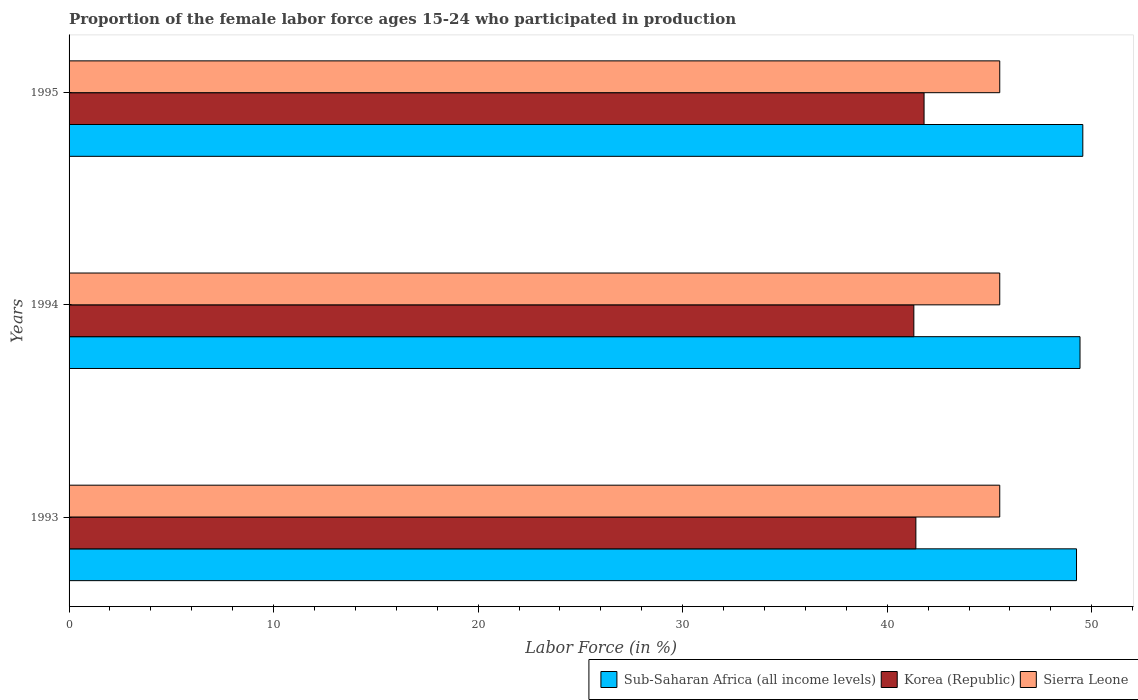Are the number of bars per tick equal to the number of legend labels?
Offer a very short reply. Yes. Are the number of bars on each tick of the Y-axis equal?
Offer a very short reply. Yes. How many bars are there on the 1st tick from the top?
Ensure brevity in your answer.  3. In how many cases, is the number of bars for a given year not equal to the number of legend labels?
Give a very brief answer. 0. What is the proportion of the female labor force who participated in production in Sub-Saharan Africa (all income levels) in 1994?
Your answer should be compact. 49.42. Across all years, what is the maximum proportion of the female labor force who participated in production in Korea (Republic)?
Offer a very short reply. 41.8. Across all years, what is the minimum proportion of the female labor force who participated in production in Sierra Leone?
Keep it short and to the point. 45.5. In which year was the proportion of the female labor force who participated in production in Korea (Republic) minimum?
Your answer should be compact. 1994. What is the total proportion of the female labor force who participated in production in Sierra Leone in the graph?
Offer a terse response. 136.5. What is the difference between the proportion of the female labor force who participated in production in Korea (Republic) in 1994 and that in 1995?
Offer a terse response. -0.5. What is the difference between the proportion of the female labor force who participated in production in Sierra Leone in 1993 and the proportion of the female labor force who participated in production in Korea (Republic) in 1994?
Offer a terse response. 4.2. What is the average proportion of the female labor force who participated in production in Korea (Republic) per year?
Your response must be concise. 41.5. In the year 1993, what is the difference between the proportion of the female labor force who participated in production in Sub-Saharan Africa (all income levels) and proportion of the female labor force who participated in production in Korea (Republic)?
Offer a terse response. 7.85. What is the ratio of the proportion of the female labor force who participated in production in Sub-Saharan Africa (all income levels) in 1994 to that in 1995?
Give a very brief answer. 1. Is the proportion of the female labor force who participated in production in Korea (Republic) in 1993 less than that in 1995?
Your response must be concise. Yes. Is the difference between the proportion of the female labor force who participated in production in Sub-Saharan Africa (all income levels) in 1993 and 1994 greater than the difference between the proportion of the female labor force who participated in production in Korea (Republic) in 1993 and 1994?
Give a very brief answer. No. What is the difference between the highest and the second highest proportion of the female labor force who participated in production in Korea (Republic)?
Keep it short and to the point. 0.4. In how many years, is the proportion of the female labor force who participated in production in Sierra Leone greater than the average proportion of the female labor force who participated in production in Sierra Leone taken over all years?
Provide a succinct answer. 0. What does the 3rd bar from the top in 1994 represents?
Provide a short and direct response. Sub-Saharan Africa (all income levels). What does the 1st bar from the bottom in 1995 represents?
Your answer should be compact. Sub-Saharan Africa (all income levels). Is it the case that in every year, the sum of the proportion of the female labor force who participated in production in Sub-Saharan Africa (all income levels) and proportion of the female labor force who participated in production in Korea (Republic) is greater than the proportion of the female labor force who participated in production in Sierra Leone?
Your answer should be very brief. Yes. How many bars are there?
Keep it short and to the point. 9. Are all the bars in the graph horizontal?
Provide a short and direct response. Yes. What is the difference between two consecutive major ticks on the X-axis?
Keep it short and to the point. 10. Where does the legend appear in the graph?
Make the answer very short. Bottom right. How many legend labels are there?
Provide a short and direct response. 3. How are the legend labels stacked?
Offer a terse response. Horizontal. What is the title of the graph?
Ensure brevity in your answer.  Proportion of the female labor force ages 15-24 who participated in production. What is the label or title of the X-axis?
Ensure brevity in your answer.  Labor Force (in %). What is the label or title of the Y-axis?
Provide a succinct answer. Years. What is the Labor Force (in %) of Sub-Saharan Africa (all income levels) in 1993?
Your response must be concise. 49.25. What is the Labor Force (in %) in Korea (Republic) in 1993?
Your response must be concise. 41.4. What is the Labor Force (in %) of Sierra Leone in 1993?
Your answer should be very brief. 45.5. What is the Labor Force (in %) of Sub-Saharan Africa (all income levels) in 1994?
Ensure brevity in your answer.  49.42. What is the Labor Force (in %) in Korea (Republic) in 1994?
Your answer should be very brief. 41.3. What is the Labor Force (in %) in Sierra Leone in 1994?
Your answer should be compact. 45.5. What is the Labor Force (in %) in Sub-Saharan Africa (all income levels) in 1995?
Ensure brevity in your answer.  49.56. What is the Labor Force (in %) of Korea (Republic) in 1995?
Keep it short and to the point. 41.8. What is the Labor Force (in %) of Sierra Leone in 1995?
Give a very brief answer. 45.5. Across all years, what is the maximum Labor Force (in %) in Sub-Saharan Africa (all income levels)?
Offer a very short reply. 49.56. Across all years, what is the maximum Labor Force (in %) in Korea (Republic)?
Your answer should be very brief. 41.8. Across all years, what is the maximum Labor Force (in %) in Sierra Leone?
Provide a succinct answer. 45.5. Across all years, what is the minimum Labor Force (in %) in Sub-Saharan Africa (all income levels)?
Offer a very short reply. 49.25. Across all years, what is the minimum Labor Force (in %) of Korea (Republic)?
Make the answer very short. 41.3. Across all years, what is the minimum Labor Force (in %) of Sierra Leone?
Your answer should be compact. 45.5. What is the total Labor Force (in %) of Sub-Saharan Africa (all income levels) in the graph?
Provide a succinct answer. 148.24. What is the total Labor Force (in %) of Korea (Republic) in the graph?
Offer a very short reply. 124.5. What is the total Labor Force (in %) in Sierra Leone in the graph?
Your answer should be compact. 136.5. What is the difference between the Labor Force (in %) in Sub-Saharan Africa (all income levels) in 1993 and that in 1994?
Your answer should be very brief. -0.17. What is the difference between the Labor Force (in %) in Korea (Republic) in 1993 and that in 1994?
Your answer should be very brief. 0.1. What is the difference between the Labor Force (in %) of Sub-Saharan Africa (all income levels) in 1993 and that in 1995?
Offer a terse response. -0.31. What is the difference between the Labor Force (in %) in Korea (Republic) in 1993 and that in 1995?
Offer a very short reply. -0.4. What is the difference between the Labor Force (in %) in Sierra Leone in 1993 and that in 1995?
Your response must be concise. 0. What is the difference between the Labor Force (in %) in Sub-Saharan Africa (all income levels) in 1994 and that in 1995?
Ensure brevity in your answer.  -0.14. What is the difference between the Labor Force (in %) of Sub-Saharan Africa (all income levels) in 1993 and the Labor Force (in %) of Korea (Republic) in 1994?
Give a very brief answer. 7.95. What is the difference between the Labor Force (in %) in Sub-Saharan Africa (all income levels) in 1993 and the Labor Force (in %) in Sierra Leone in 1994?
Offer a terse response. 3.75. What is the difference between the Labor Force (in %) in Sub-Saharan Africa (all income levels) in 1993 and the Labor Force (in %) in Korea (Republic) in 1995?
Offer a very short reply. 7.45. What is the difference between the Labor Force (in %) in Sub-Saharan Africa (all income levels) in 1993 and the Labor Force (in %) in Sierra Leone in 1995?
Provide a short and direct response. 3.75. What is the difference between the Labor Force (in %) of Korea (Republic) in 1993 and the Labor Force (in %) of Sierra Leone in 1995?
Your answer should be very brief. -4.1. What is the difference between the Labor Force (in %) of Sub-Saharan Africa (all income levels) in 1994 and the Labor Force (in %) of Korea (Republic) in 1995?
Your response must be concise. 7.62. What is the difference between the Labor Force (in %) of Sub-Saharan Africa (all income levels) in 1994 and the Labor Force (in %) of Sierra Leone in 1995?
Give a very brief answer. 3.92. What is the difference between the Labor Force (in %) of Korea (Republic) in 1994 and the Labor Force (in %) of Sierra Leone in 1995?
Your response must be concise. -4.2. What is the average Labor Force (in %) of Sub-Saharan Africa (all income levels) per year?
Your answer should be compact. 49.41. What is the average Labor Force (in %) of Korea (Republic) per year?
Your answer should be very brief. 41.5. What is the average Labor Force (in %) in Sierra Leone per year?
Provide a short and direct response. 45.5. In the year 1993, what is the difference between the Labor Force (in %) of Sub-Saharan Africa (all income levels) and Labor Force (in %) of Korea (Republic)?
Provide a succinct answer. 7.85. In the year 1993, what is the difference between the Labor Force (in %) of Sub-Saharan Africa (all income levels) and Labor Force (in %) of Sierra Leone?
Your response must be concise. 3.75. In the year 1994, what is the difference between the Labor Force (in %) of Sub-Saharan Africa (all income levels) and Labor Force (in %) of Korea (Republic)?
Provide a succinct answer. 8.12. In the year 1994, what is the difference between the Labor Force (in %) in Sub-Saharan Africa (all income levels) and Labor Force (in %) in Sierra Leone?
Provide a succinct answer. 3.92. In the year 1994, what is the difference between the Labor Force (in %) in Korea (Republic) and Labor Force (in %) in Sierra Leone?
Provide a short and direct response. -4.2. In the year 1995, what is the difference between the Labor Force (in %) of Sub-Saharan Africa (all income levels) and Labor Force (in %) of Korea (Republic)?
Give a very brief answer. 7.76. In the year 1995, what is the difference between the Labor Force (in %) of Sub-Saharan Africa (all income levels) and Labor Force (in %) of Sierra Leone?
Offer a very short reply. 4.06. In the year 1995, what is the difference between the Labor Force (in %) of Korea (Republic) and Labor Force (in %) of Sierra Leone?
Your response must be concise. -3.7. What is the ratio of the Labor Force (in %) of Sub-Saharan Africa (all income levels) in 1993 to that in 1994?
Give a very brief answer. 1. What is the ratio of the Labor Force (in %) of Sub-Saharan Africa (all income levels) in 1993 to that in 1995?
Provide a succinct answer. 0.99. What is the ratio of the Labor Force (in %) of Korea (Republic) in 1993 to that in 1995?
Ensure brevity in your answer.  0.99. What is the ratio of the Labor Force (in %) in Sierra Leone in 1993 to that in 1995?
Provide a succinct answer. 1. What is the ratio of the Labor Force (in %) in Sub-Saharan Africa (all income levels) in 1994 to that in 1995?
Give a very brief answer. 1. What is the ratio of the Labor Force (in %) of Korea (Republic) in 1994 to that in 1995?
Give a very brief answer. 0.99. What is the difference between the highest and the second highest Labor Force (in %) of Sub-Saharan Africa (all income levels)?
Make the answer very short. 0.14. What is the difference between the highest and the lowest Labor Force (in %) of Sub-Saharan Africa (all income levels)?
Your answer should be very brief. 0.31. What is the difference between the highest and the lowest Labor Force (in %) in Korea (Republic)?
Offer a very short reply. 0.5. What is the difference between the highest and the lowest Labor Force (in %) in Sierra Leone?
Your response must be concise. 0. 